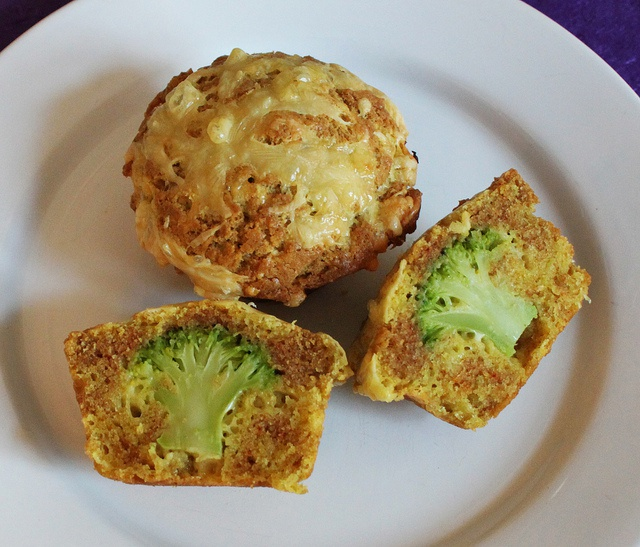Describe the objects in this image and their specific colors. I can see broccoli in black and olive tones and broccoli in black, olive, lightgreen, and khaki tones in this image. 